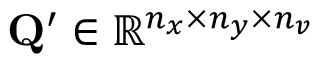Convert formula to latex. <formula><loc_0><loc_0><loc_500><loc_500>Q ^ { \prime } \in \mathbb { R } ^ { n _ { x } \times n _ { y } \times n _ { v } }</formula> 